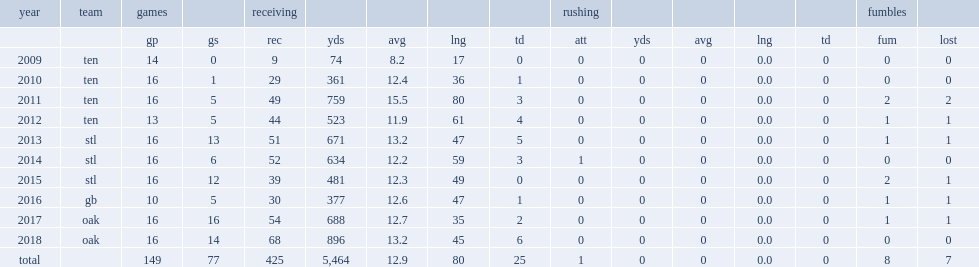Could you parse the entire table? {'header': ['year', 'team', 'games', '', 'receiving', '', '', '', '', 'rushing', '', '', '', '', 'fumbles', ''], 'rows': [['', '', 'gp', 'gs', 'rec', 'yds', 'avg', 'lng', 'td', 'att', 'yds', 'avg', 'lng', 'td', 'fum', 'lost'], ['2009', 'ten', '14', '0', '9', '74', '8.2', '17', '0', '0', '0', '0', '0.0', '0', '0', '0'], ['2010', 'ten', '16', '1', '29', '361', '12.4', '36', '1', '0', '0', '0', '0.0', '0', '0', '0'], ['2011', 'ten', '16', '5', '49', '759', '15.5', '80', '3', '0', '0', '0', '0.0', '0', '2', '2'], ['2012', 'ten', '13', '5', '44', '523', '11.9', '61', '4', '0', '0', '0', '0.0', '0', '1', '1'], ['2013', 'stl', '16', '13', '51', '671', '13.2', '47', '5', '0', '0', '0', '0.0', '0', '1', '1'], ['2014', 'stl', '16', '6', '52', '634', '12.2', '59', '3', '1', '0', '0', '0.0', '0', '0', '0'], ['2015', 'stl', '16', '12', '39', '481', '12.3', '49', '0', '0', '0', '0', '0.0', '0', '2', '1'], ['2016', 'gb', '10', '5', '30', '377', '12.6', '47', '1', '0', '0', '0', '0.0', '0', '1', '1'], ['2017', 'oak', '16', '16', '54', '688', '12.7', '35', '2', '0', '0', '0', '0.0', '0', '1', '1'], ['2018', 'oak', '16', '14', '68', '896', '13.2', '45', '6', '0', '0', '0', '0.0', '0', '0', '0'], ['total', '', '149', '77', '425', '5,464', '12.9', '80', '25', '1', '0', '0', '0.0', '0', '8', '7']]} How many receptions did cook get in 2013? 51.0. 